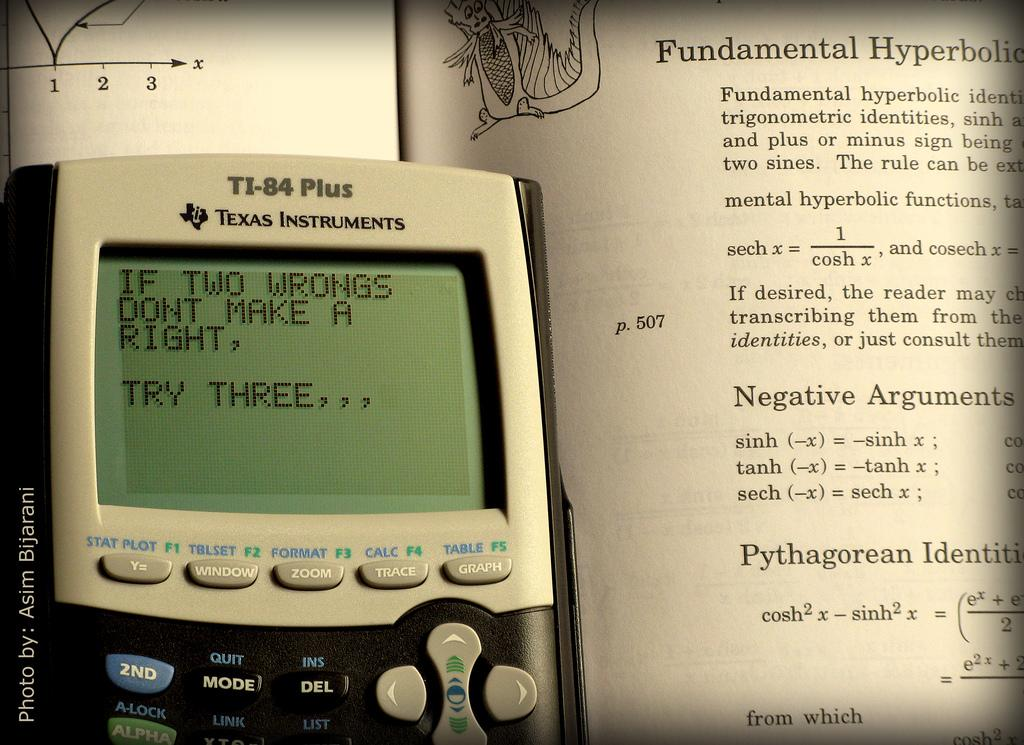<image>
Share a concise interpretation of the image provided. A TI-84 calculator sitting on top of an open textbook. 